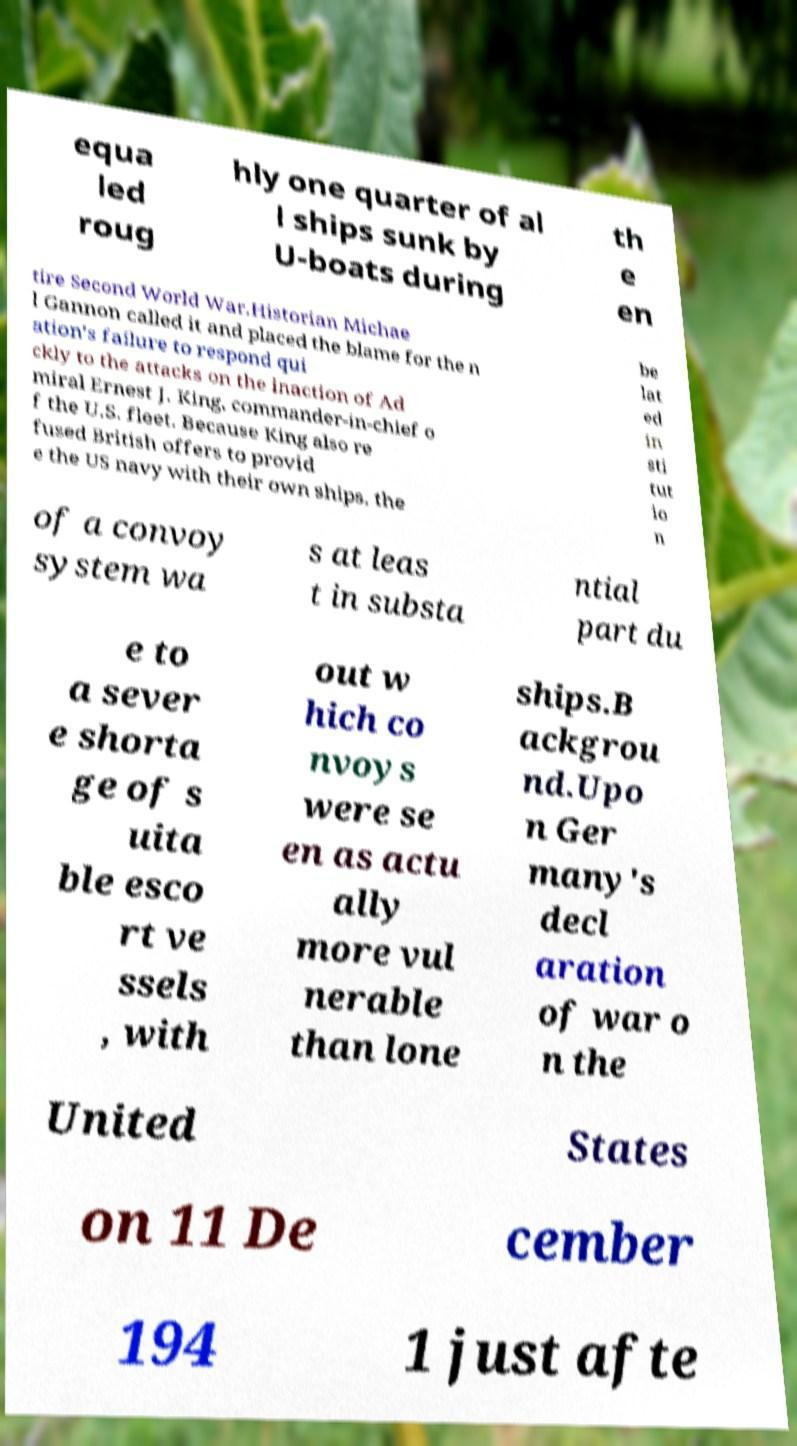Can you read and provide the text displayed in the image?This photo seems to have some interesting text. Can you extract and type it out for me? equa led roug hly one quarter of al l ships sunk by U-boats during th e en tire Second World War.Historian Michae l Gannon called it and placed the blame for the n ation's failure to respond qui ckly to the attacks on the inaction of Ad miral Ernest J. King, commander-in-chief o f the U.S. fleet. Because King also re fused British offers to provid e the US navy with their own ships, the be lat ed in sti tut io n of a convoy system wa s at leas t in substa ntial part du e to a sever e shorta ge of s uita ble esco rt ve ssels , with out w hich co nvoys were se en as actu ally more vul nerable than lone ships.B ackgrou nd.Upo n Ger many's decl aration of war o n the United States on 11 De cember 194 1 just afte 